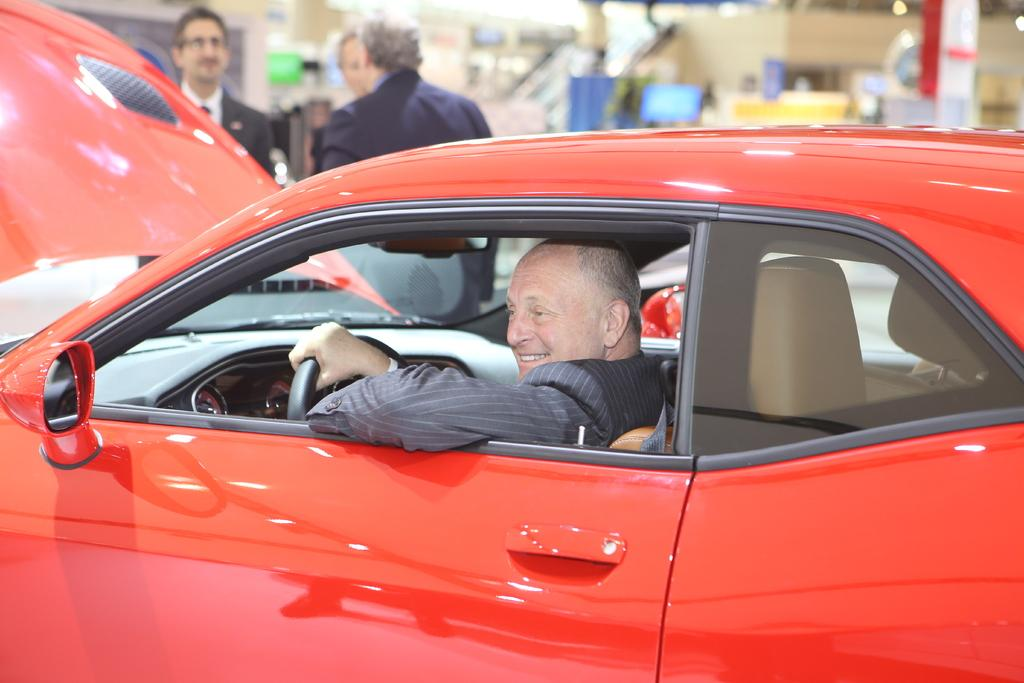What type of vehicle is in the image? There is a red car in the image. Who is inside the car? A man is sitting in the car and holding the steering wheel. What is happening behind the car? There are people standing behind the car. What color is the background of the image? The background color is blue. What musical instrument is the man playing in the car? There is no musical instrument present in the image; the man is holding the steering wheel. 